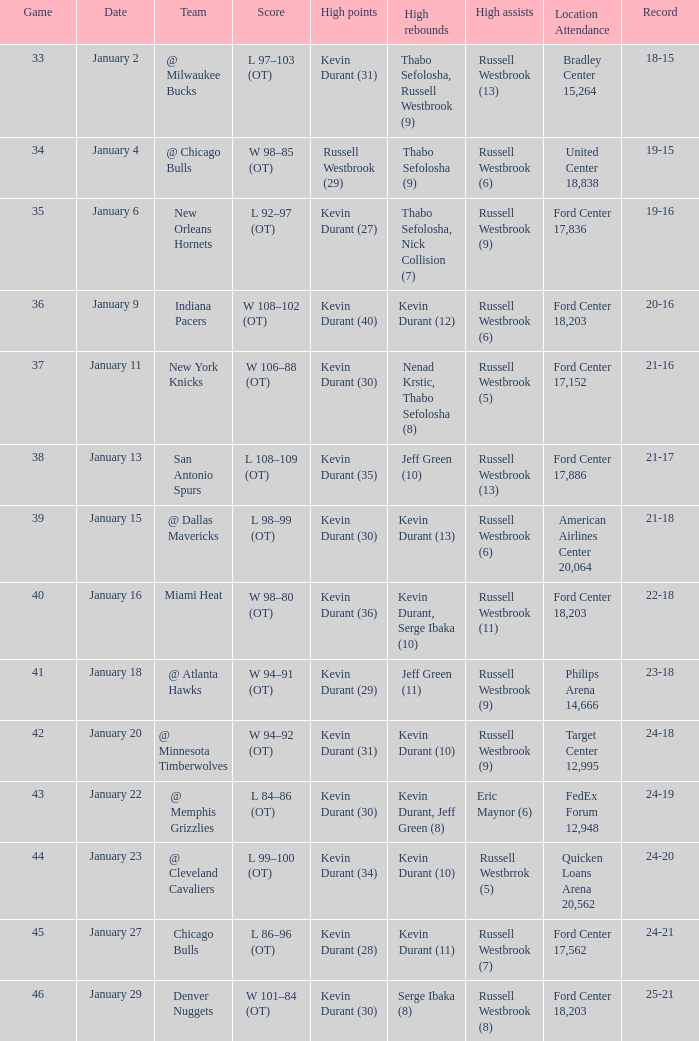List the least significant game scheduled for january 2 46.0. 